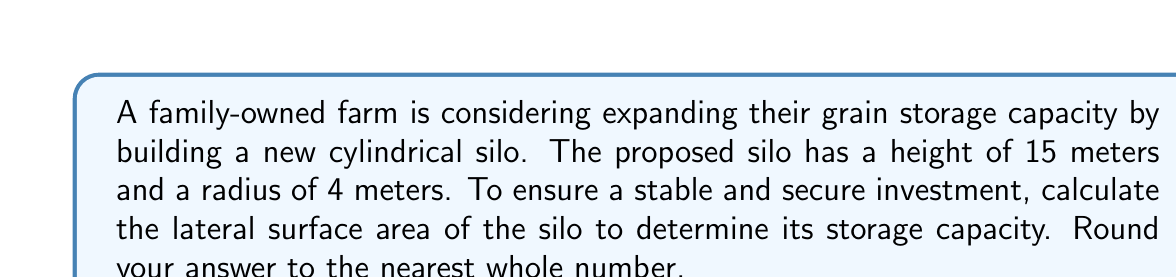Provide a solution to this math problem. Let's approach this step-by-step:

1) The lateral surface area of a cylinder (excluding the top and bottom) is given by the formula:

   $$ A = 2\pi rh $$

   Where $r$ is the radius and $h$ is the height.

2) We are given:
   $r = 4$ meters
   $h = 15$ meters

3) Let's substitute these values into our formula:

   $$ A = 2\pi (4)(15) $$

4) Simplify:
   $$ A = 2\pi (60) $$
   $$ A = 120\pi $$

5) Now, let's calculate this:
   $$ A = 120 * 3.14159... $$
   $$ A = 376.99... $$

6) Rounding to the nearest whole number:
   $$ A \approx 377 \text{ square meters} $$

This lateral surface area represents the amount of material needed to cover the sides of the silo, which directly relates to its storage capacity. A larger surface area indicates a larger volume and thus greater storage capacity, ensuring a stable and secure investment for the farm's future.
Answer: 377 m² 